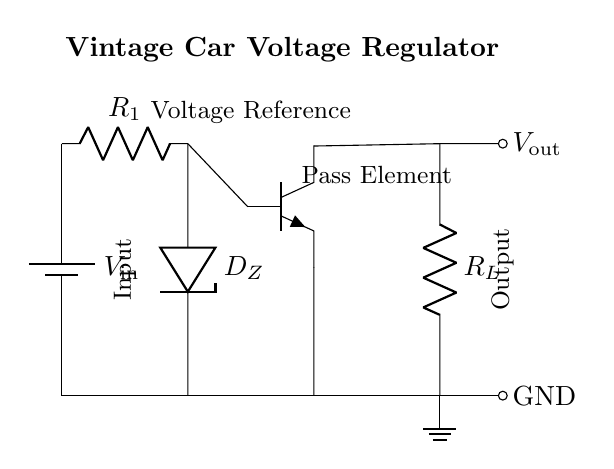What is the input voltage source labeled? The input voltage source is labeled as "V_in", which indicates that this is the voltage supplied to the circuit.
Answer: V_in What type of diode is used in the circuit? The circuit features a Zener diode indicated by the label "D_Z", which is often used for voltage regulation by providing a stable output voltage despite variations in input.
Answer: Zener diode How many resistors are present in the circuit? There are two resistors in the circuit: one labeled "R_1" connected to the input voltage and another labeled "R_L" providing a load.
Answer: Two What function does the transistor serve in this circuit? The transistor, labeled as "Pass Element", functions as a current amplifier and is key in maintaining output voltage stability through controlling the flow of current based on the input voltage.
Answer: Current amplifier What component is responsible for voltage regulation? The Zener diode "D_Z" is responsible for maintaining a stable output voltage, as it allows current to flow in reverse, helping to set the output voltage across the load resistor.
Answer: Zener diode What is the output of this voltage regulator labeled? The output of the regulator is labeled as "V_out", which represents the regulated voltage being supplied to the connected load.
Answer: V_out What is the configuration of the connections at the output side? The connections at the output side directly supply voltage to the load resistor "R_L", with the output "V_out" indicating the voltage measurement point after the load.
Answer: Series configuration 